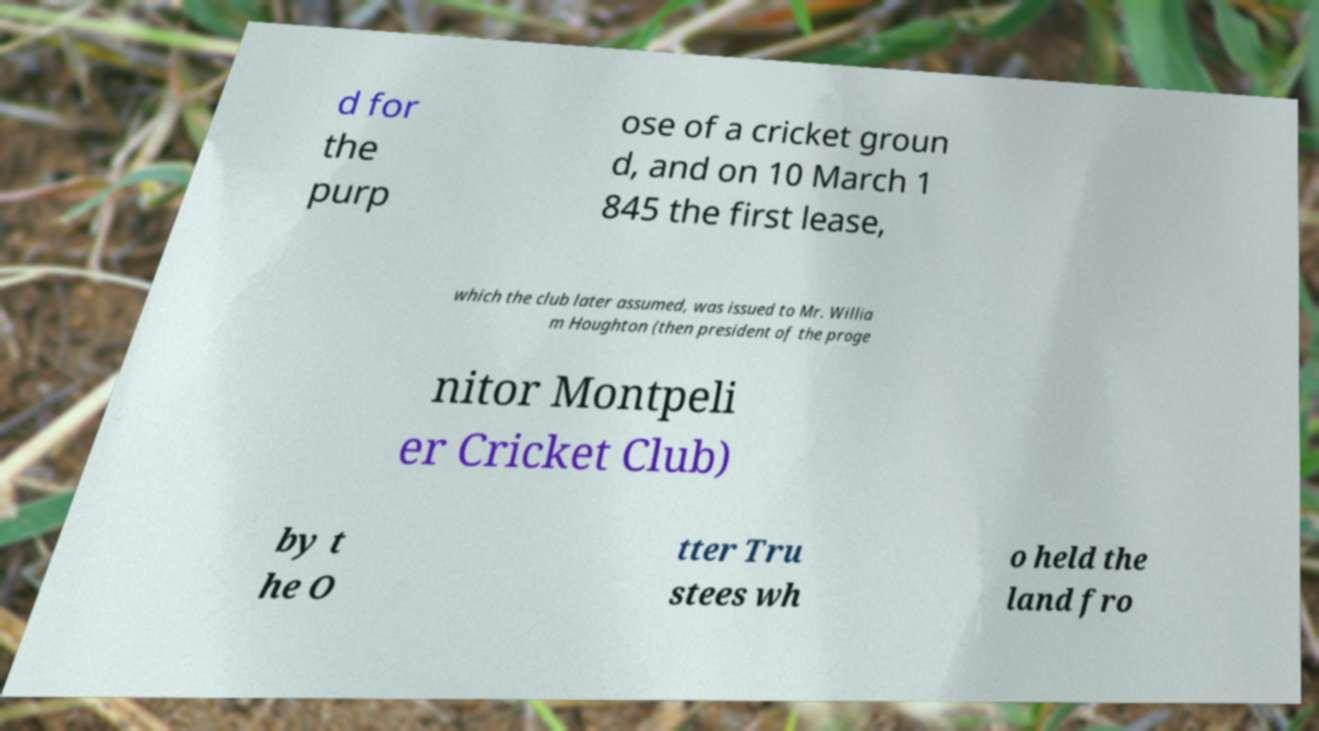Could you extract and type out the text from this image? d for the purp ose of a cricket groun d, and on 10 March 1 845 the first lease, which the club later assumed, was issued to Mr. Willia m Houghton (then president of the proge nitor Montpeli er Cricket Club) by t he O tter Tru stees wh o held the land fro 